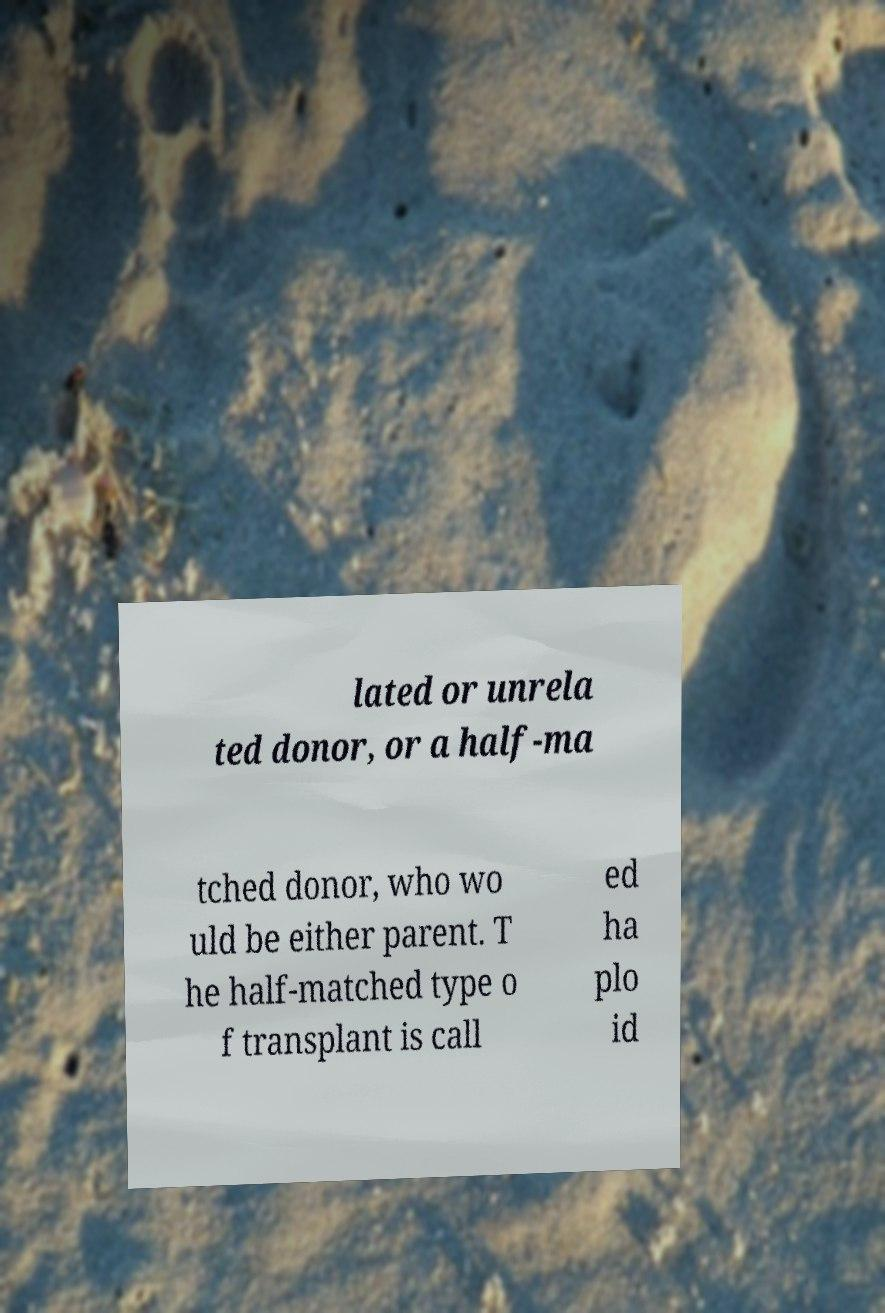Could you assist in decoding the text presented in this image and type it out clearly? lated or unrela ted donor, or a half-ma tched donor, who wo uld be either parent. T he half-matched type o f transplant is call ed ha plo id 